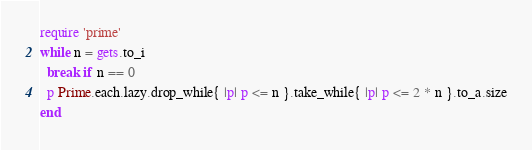Convert code to text. <code><loc_0><loc_0><loc_500><loc_500><_Ruby_>require 'prime'
while n = gets.to_i
  break if n == 0
  p Prime.each.lazy.drop_while{ |p| p <= n }.take_while{ |p| p <= 2 * n }.to_a.size
end</code> 